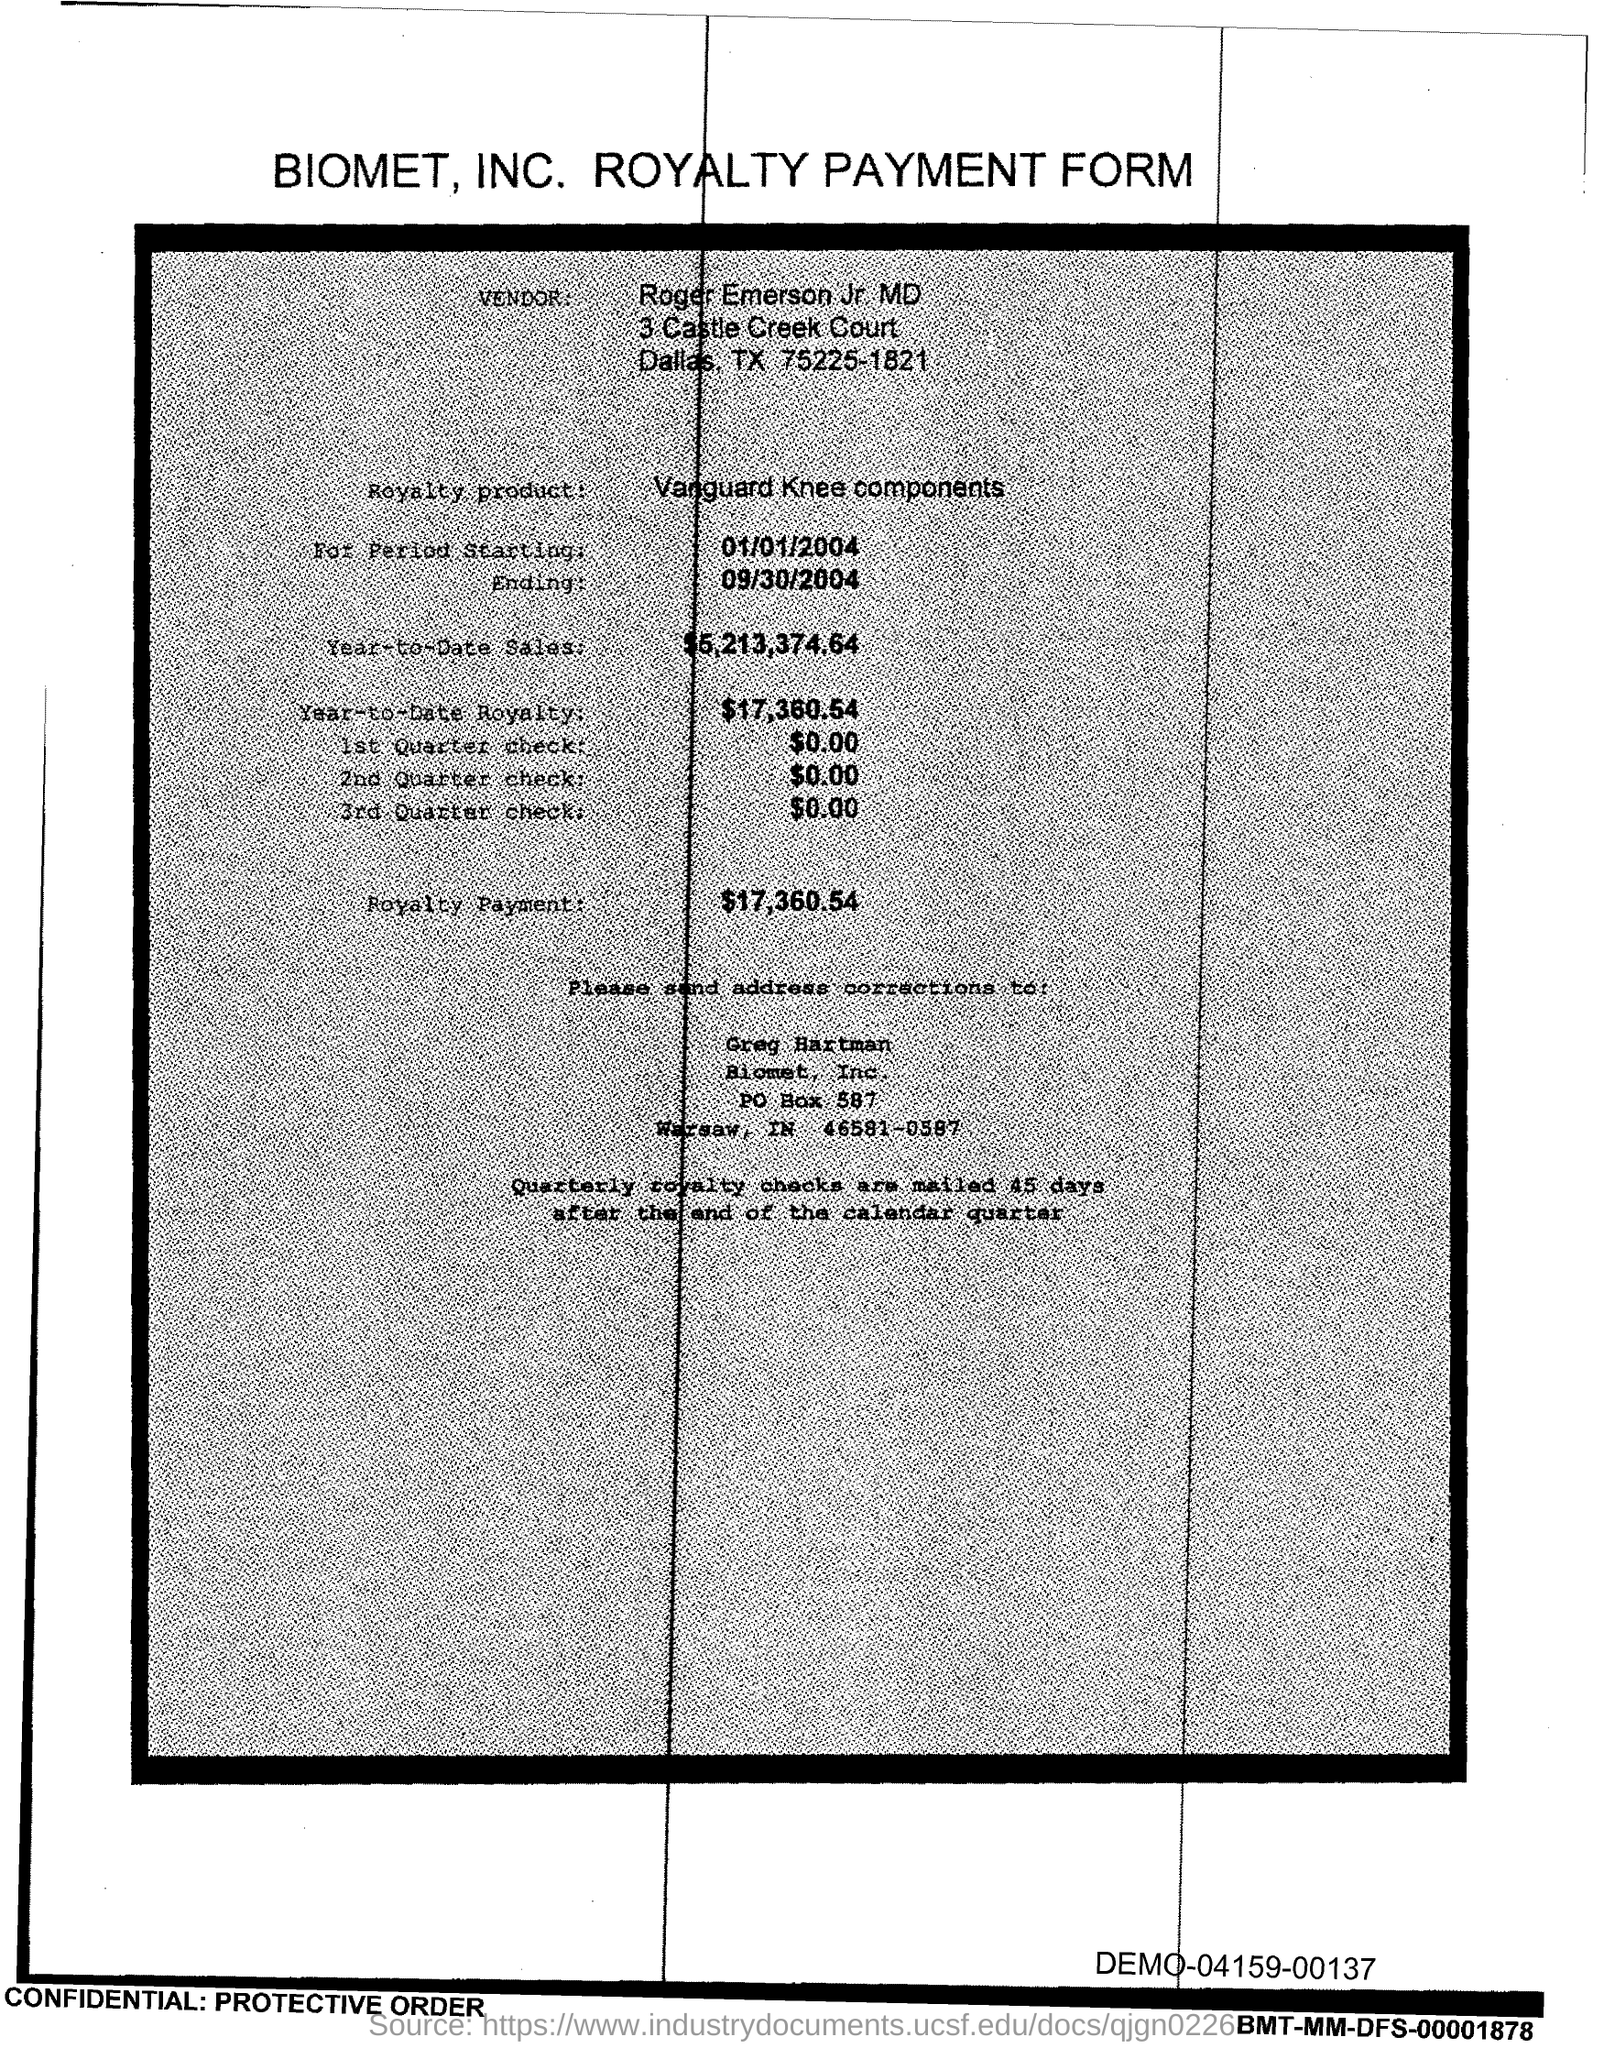Who is the vendor?
Offer a terse response. Roger Emerson Jr MD. What is the Royalty Product?
Your answer should be compact. Vanguard Knee components. What is the starting period?
Keep it short and to the point. 01/01/2004. When is it ending?
Ensure brevity in your answer.  09/30/2004. What is the year to date sales?
Offer a very short reply. $5,213,374.64. What is the year to date royalty?
Offer a very short reply. $17,360.54. What is the 1st quarter check?
Make the answer very short. $0.00. What is the 2nd quarter check?
Your answer should be compact. $0.00. What is the royalty payment?
Make the answer very short. $17,360.54. 